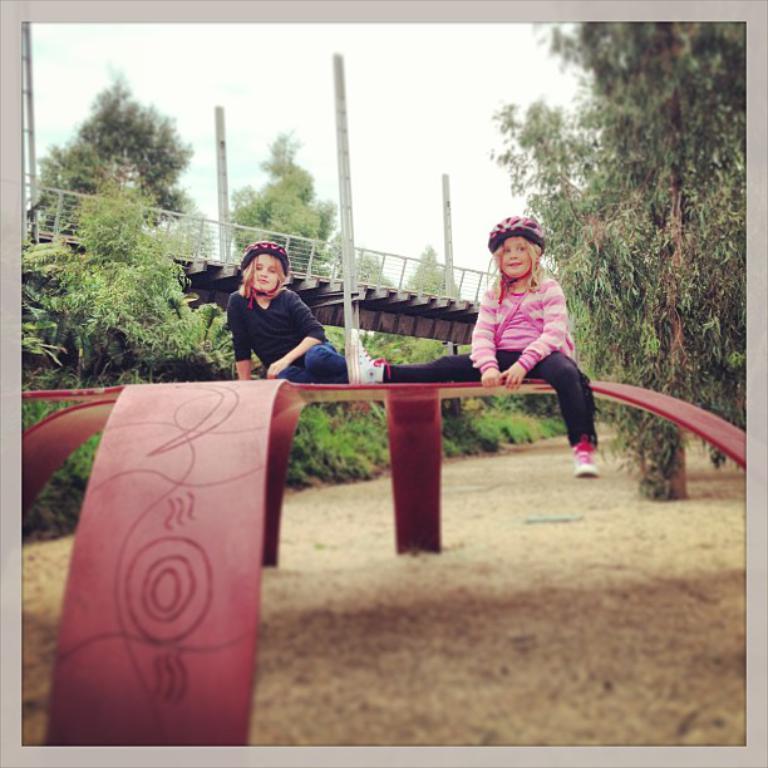How would you summarize this image in a sentence or two? There are two children. In the background we can see plants, trees, poles, bridge, and sky. 